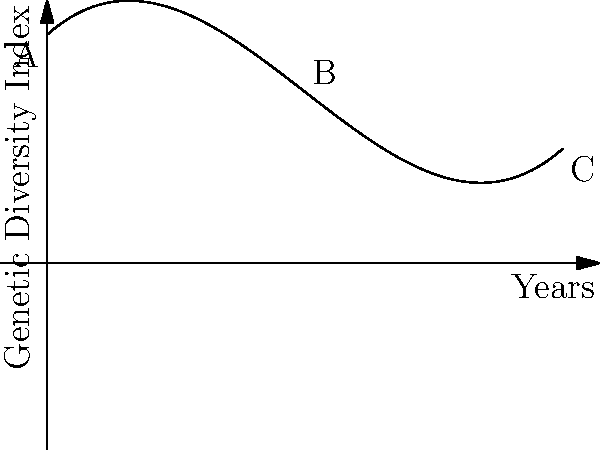The graph represents a polynomial model of genetic diversity trends in a population over 10 years. If the function is of the form $f(x) = ax^3 + bx^2 + cx + d$, where $x$ represents years and $f(x)$ represents the Genetic Diversity Index, what is the value of $a + b + c + d$? To solve this problem, we need to follow these steps:

1) The given polynomial function is of the form $f(x) = ax^3 + bx^2 + cx + d$

2) From the graph, we can observe that:
   - When x = 0 (point A), f(x) ≈ 10
   - The curve reaches a maximum around x = 5 (point B)
   - When x = 10 (point C), f(x) is slightly higher than at x = 0

3) Based on these observations and the shape of the curve, we can deduce that:
   a ≈ 0.05 (small positive coefficient for x^3 term)
   b ≈ -0.75 (negative coefficient for x^2 term to create the peak)
   c ≈ 2 (positive coefficient for x term for initial increase)
   d ≈ 10 (y-intercept)

4) The actual function represented in the graph is:
   $f(x) = 0.05x^3 - 0.75x^2 + 2x + 10$

5) To find $a + b + c + d$, we simply add these coefficients:
   0.05 + (-0.75) + 2 + 10 = 11.3

Therefore, the sum of the coefficients $a + b + c + d = 11.3$.
Answer: 11.3 